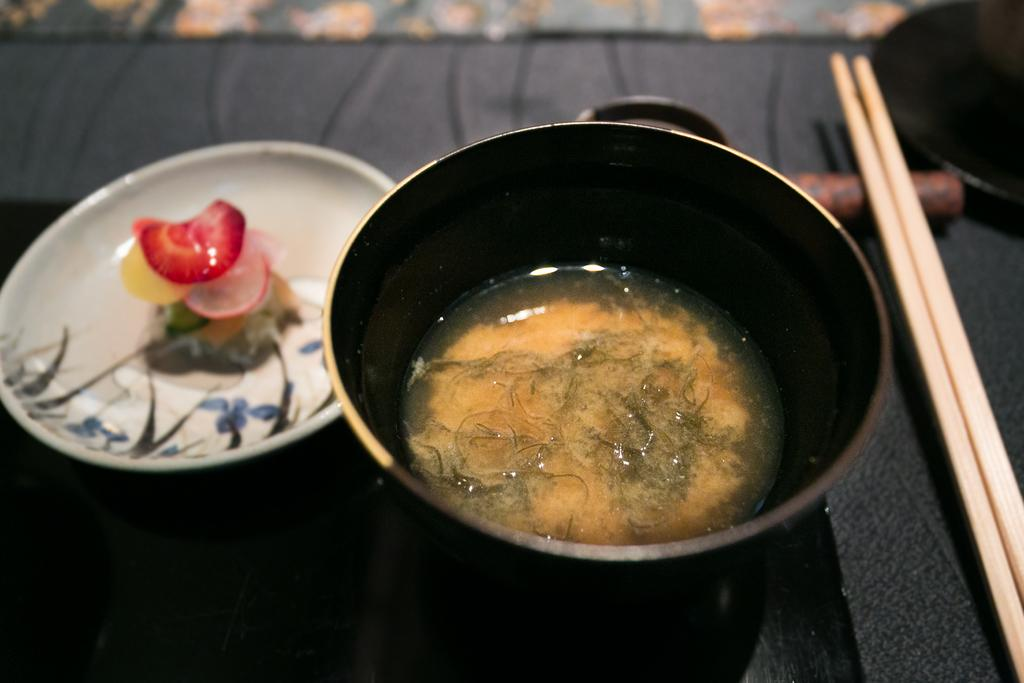What is in the bowl that is visible in the image? The bowl contains soup. What utensils are present in the image? There are chopsticks in the image. Where are the chopsticks placed? The chopsticks are kept on a tray. How many pigs can be seen walking on the road in the image? There are no pigs or roads present in the image. 